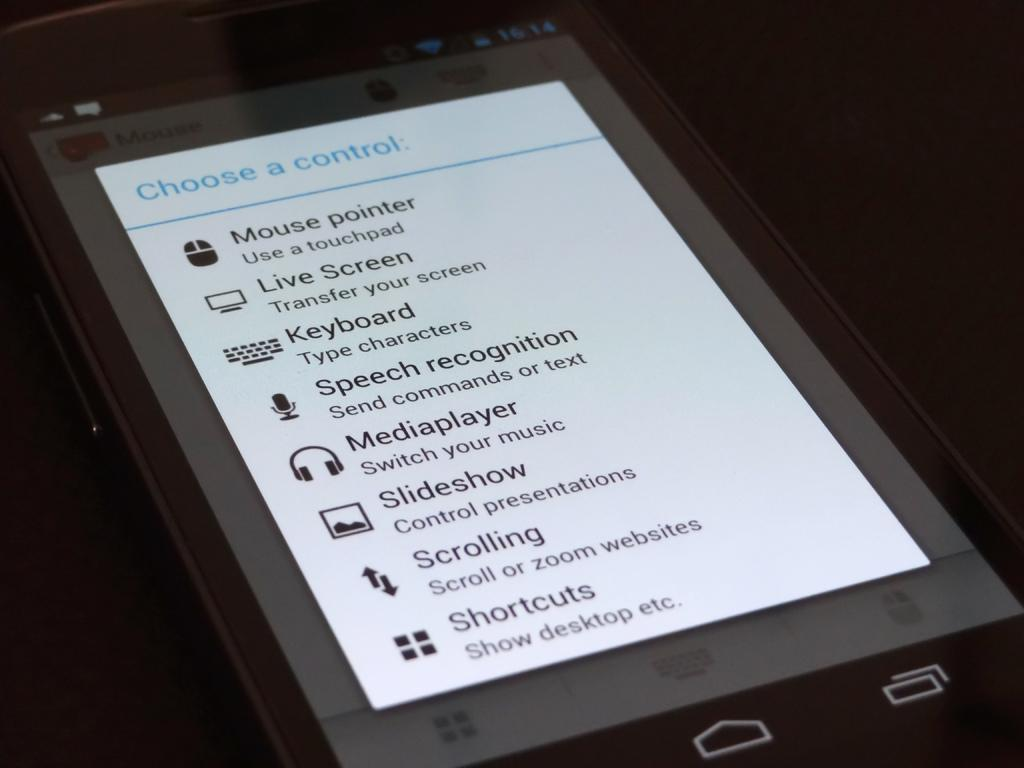Provide a one-sentence caption for the provided image. An ipad that shows the settings for the device to access the keyboard, speech recognition, Media player and other features. 